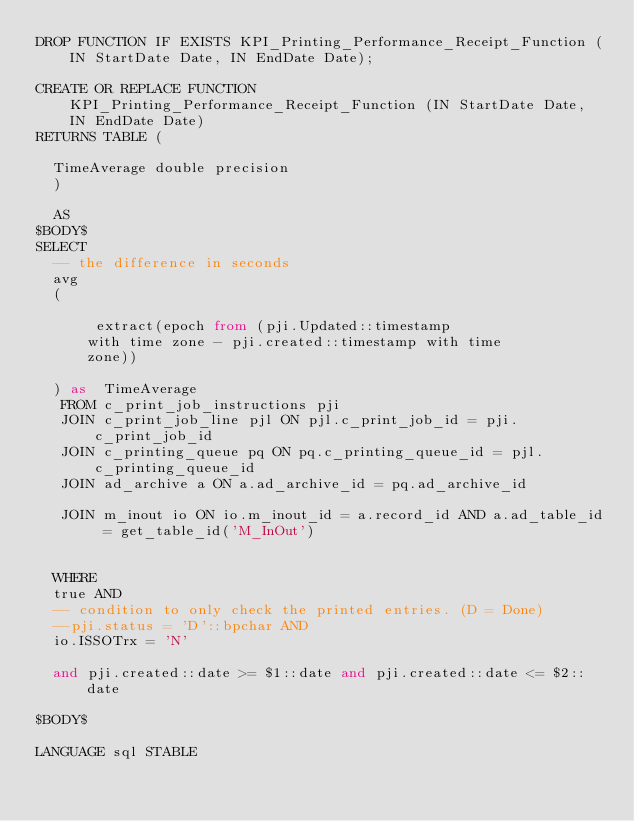<code> <loc_0><loc_0><loc_500><loc_500><_SQL_>DROP FUNCTION IF EXISTS KPI_Printing_Performance_Receipt_Function (IN StartDate Date, IN EndDate Date);

CREATE OR REPLACE FUNCTION KPI_Printing_Performance_Receipt_Function (IN StartDate Date, IN EndDate Date)
RETURNS TABLE (

	TimeAverage double precision
	)
	
	AS
$BODY$
SELECT
 	-- the difference in seconds
	avg 
	(
		
			 extract(epoch from (pji.Updated::timestamp
			with time zone - pji.created::timestamp with time
			zone)) 

	) as  TimeAverage
   FROM c_print_job_instructions pji
   JOIN c_print_job_line pjl ON pjl.c_print_job_id = pji.c_print_job_id
   JOIN c_printing_queue pq ON pq.c_printing_queue_id = pjl.c_printing_queue_id
   JOIN ad_archive a ON a.ad_archive_id = pq.ad_archive_id

   JOIN m_inout io ON io.m_inout_id = a.record_id AND a.ad_table_id = get_table_id('M_InOut')


  WHERE 
  true AND 
  -- condition to only check the printed entries. (D = Done)
  --pji.status = 'D'::bpchar AND
  io.ISSOTrx = 'N'

  and pji.created::date >= $1::date and pji.created::date <= $2::date

$BODY$

LANGUAGE sql STABLE</code> 